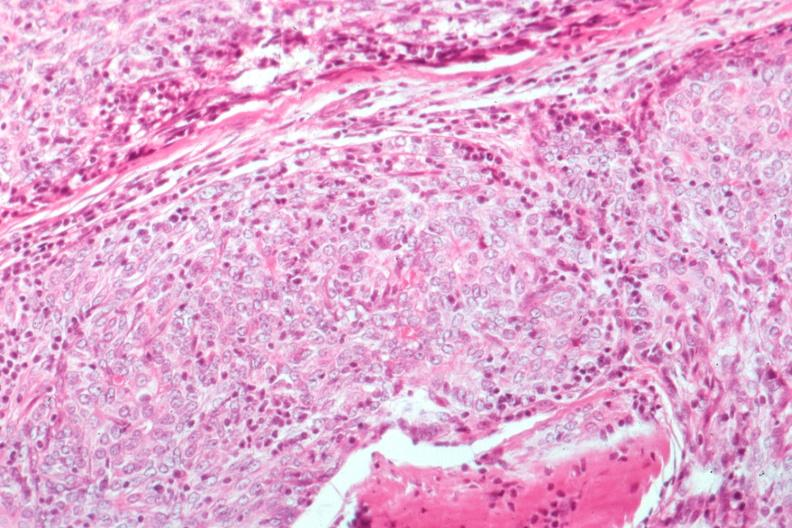does anomalous origin show epithelial lesion surgical path?
Answer the question using a single word or phrase. No 